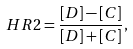<formula> <loc_0><loc_0><loc_500><loc_500>H R 2 = \frac { [ D ] - [ C ] } { [ D ] + [ C ] } ,</formula> 